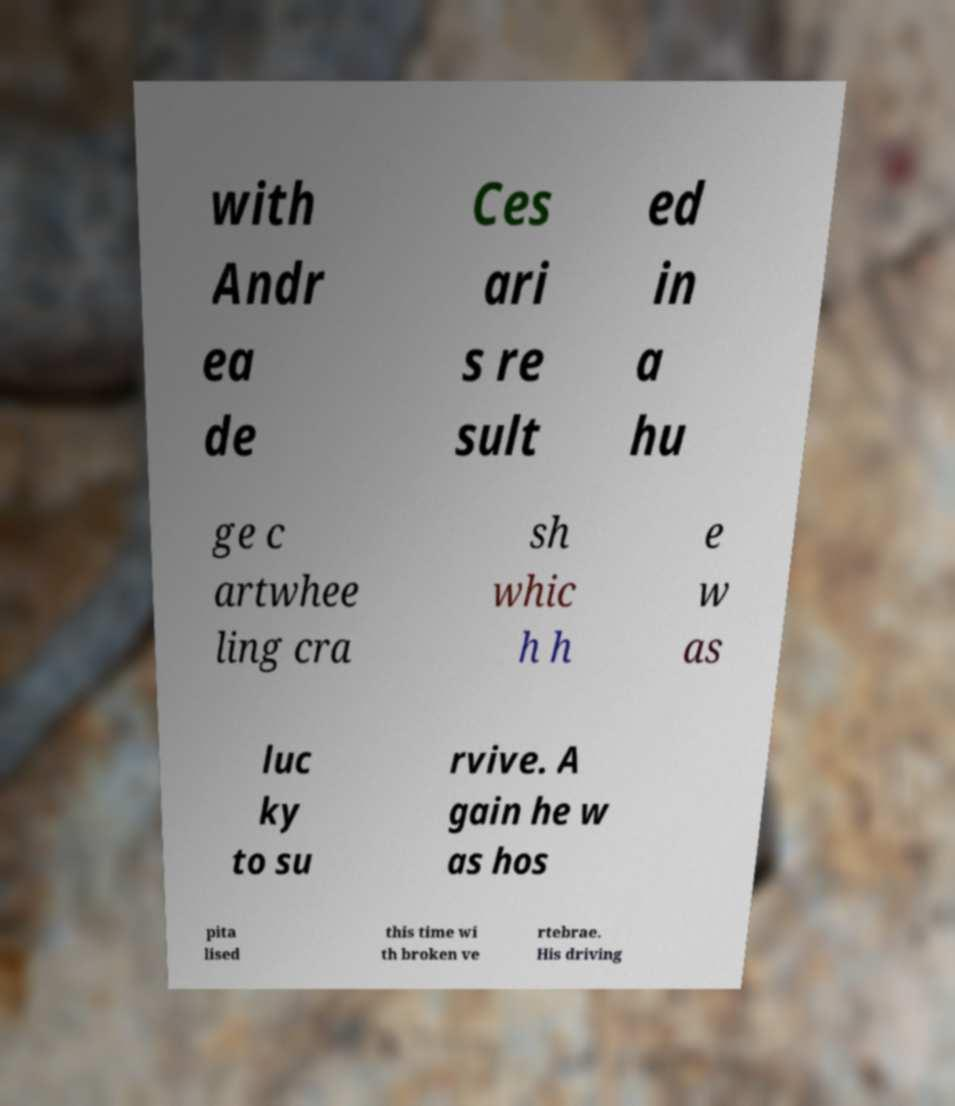Can you read and provide the text displayed in the image?This photo seems to have some interesting text. Can you extract and type it out for me? with Andr ea de Ces ari s re sult ed in a hu ge c artwhee ling cra sh whic h h e w as luc ky to su rvive. A gain he w as hos pita lised this time wi th broken ve rtebrae. His driving 